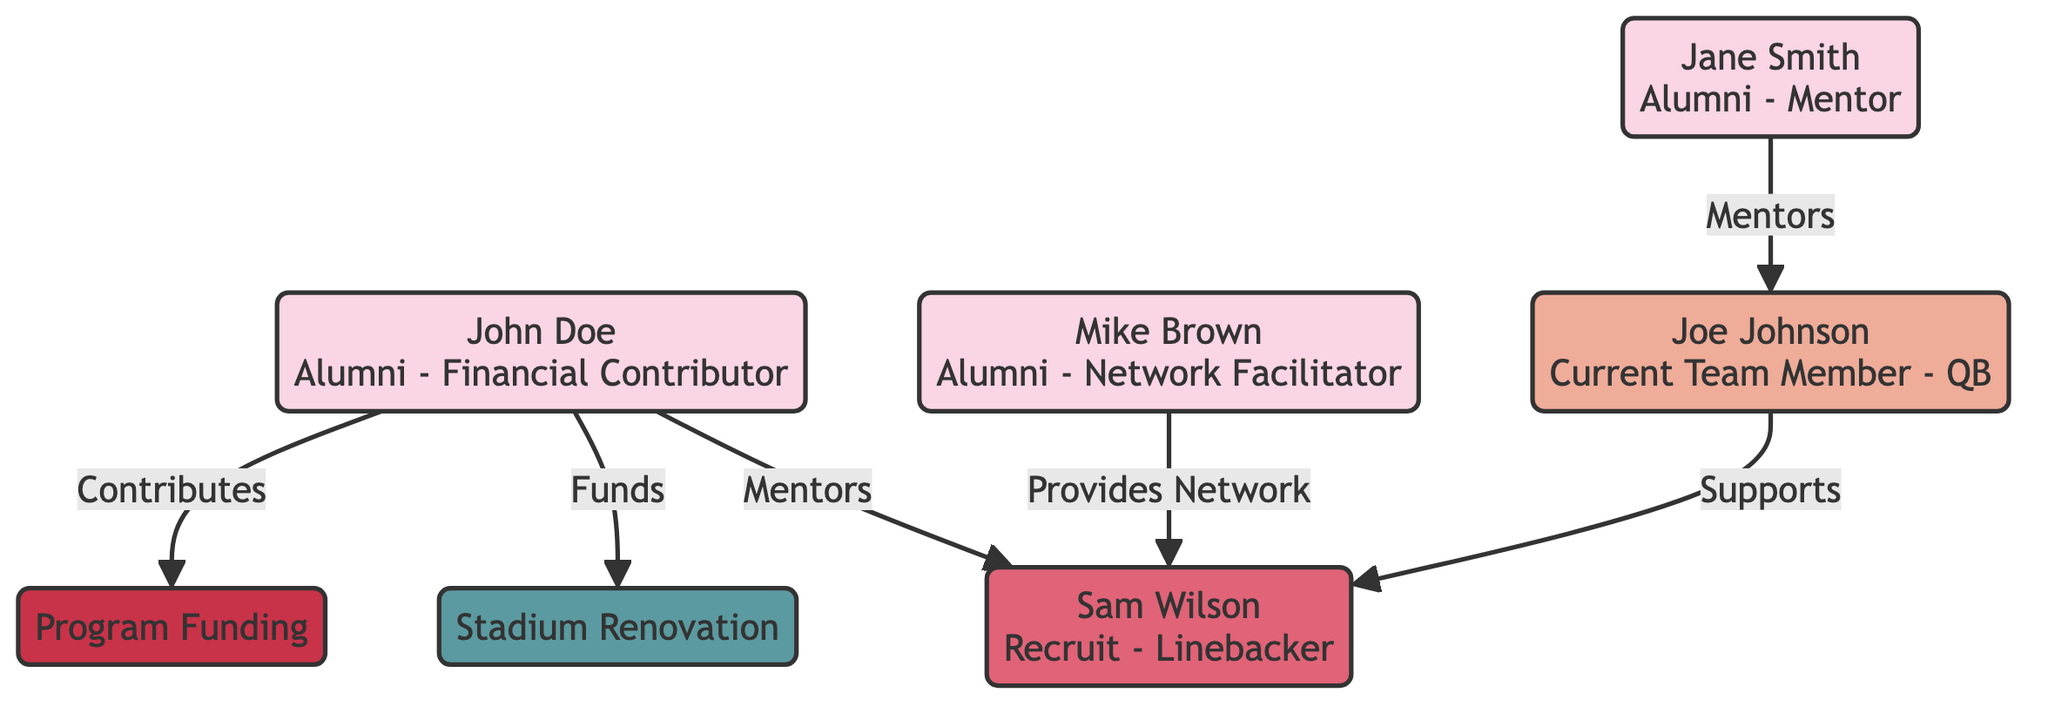What is the role of John Doe in this diagram? John Doe is identified as "Financial Contributor," contributing to the program funding and stadium renovation. This information is directly indicated in his node description.
Answer: Financial Contributor How many alumni are represented in the network diagram? The diagram displays three alumni: John Doe, Jane Smith, and Mike Brown. This can be counted from the node entries highlighting each alumni's individual contributions and roles.
Answer: 3 Who mentors Joe Johnson? The diagram specifies that Jane Smith is the mentor for Joe Johnson, as illustrated by the directed edge labeled "Mentors" connecting Jane Smith to Joe Johnson.
Answer: Jane Smith What type of contribution is associated with Mike Brown? Mike Brown is categorized as a "Network Facilitator," providing "Internship Opportunities" and "Job Placement," as seen in both his role description and the outgoing connection reflecting that he provides networks.
Answer: Network Facilitator Which initiative is funded by John Doe? John Doe funds the "Stadium Renovation," as indicated by the relationship labeled "Funds" connecting John Doe to the stadium renovation initiative node in the diagram.
Answer: Stadium Renovation How many edges are present in the diagram? The diagram shows six edges connecting various nodes, which can be counted by reviewing each relationship between the alumni, team members, and resources or initiatives.
Answer: 6 What is the primary career aspiration of Joe Johnson? Joe Johnson’s career aspiration is to become an "NFL Player," which is specified in his node description regarding his current team position.
Answer: NFL Player Which alumni provides a network for Sam Wilson? Mike Brown is the alumni who provides a network for Sam Wilson, as indicated by the connection labeled "Provides Network" in the diagram.
Answer: Mike Brown What type of resource is 'Program Funding' classified as? 'Program Funding' is classified as a "Resource" in the diagram, as denoted in its node description.
Answer: Resource 